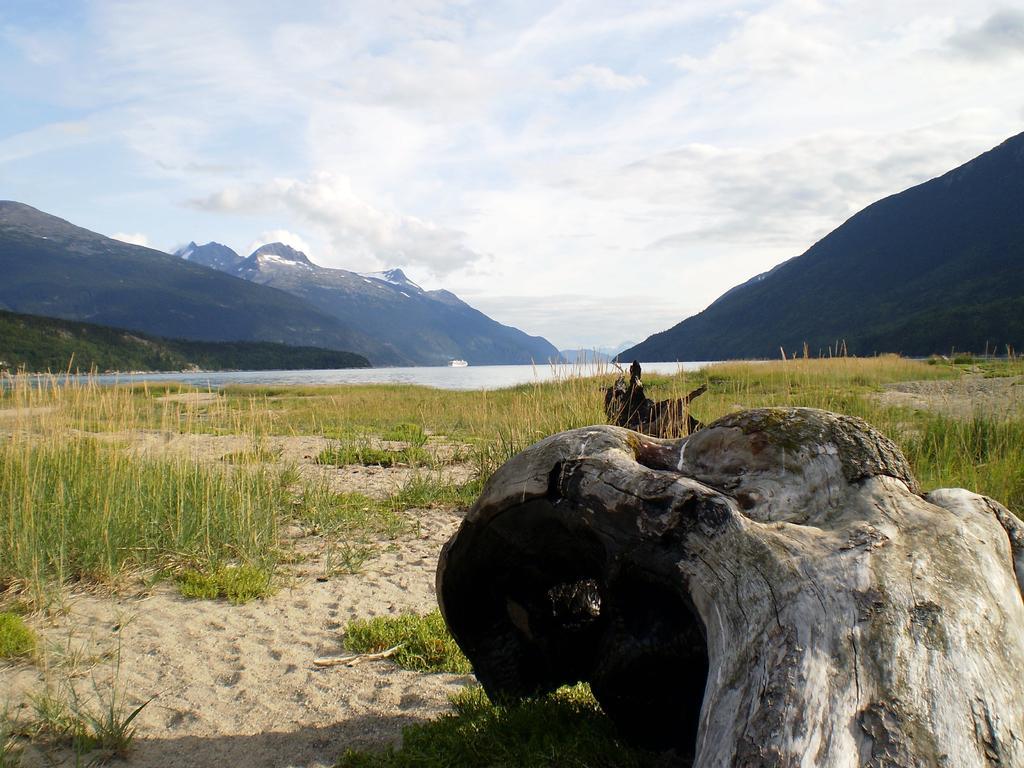Can you describe this image briefly? In this picture there is a beautiful view. In front bottom side there is a tree trunk. Behind there is a grass on the ground. In the background there is a river water and on both the sides there are some huge mountains. On the top there is a sky with white clouds. 